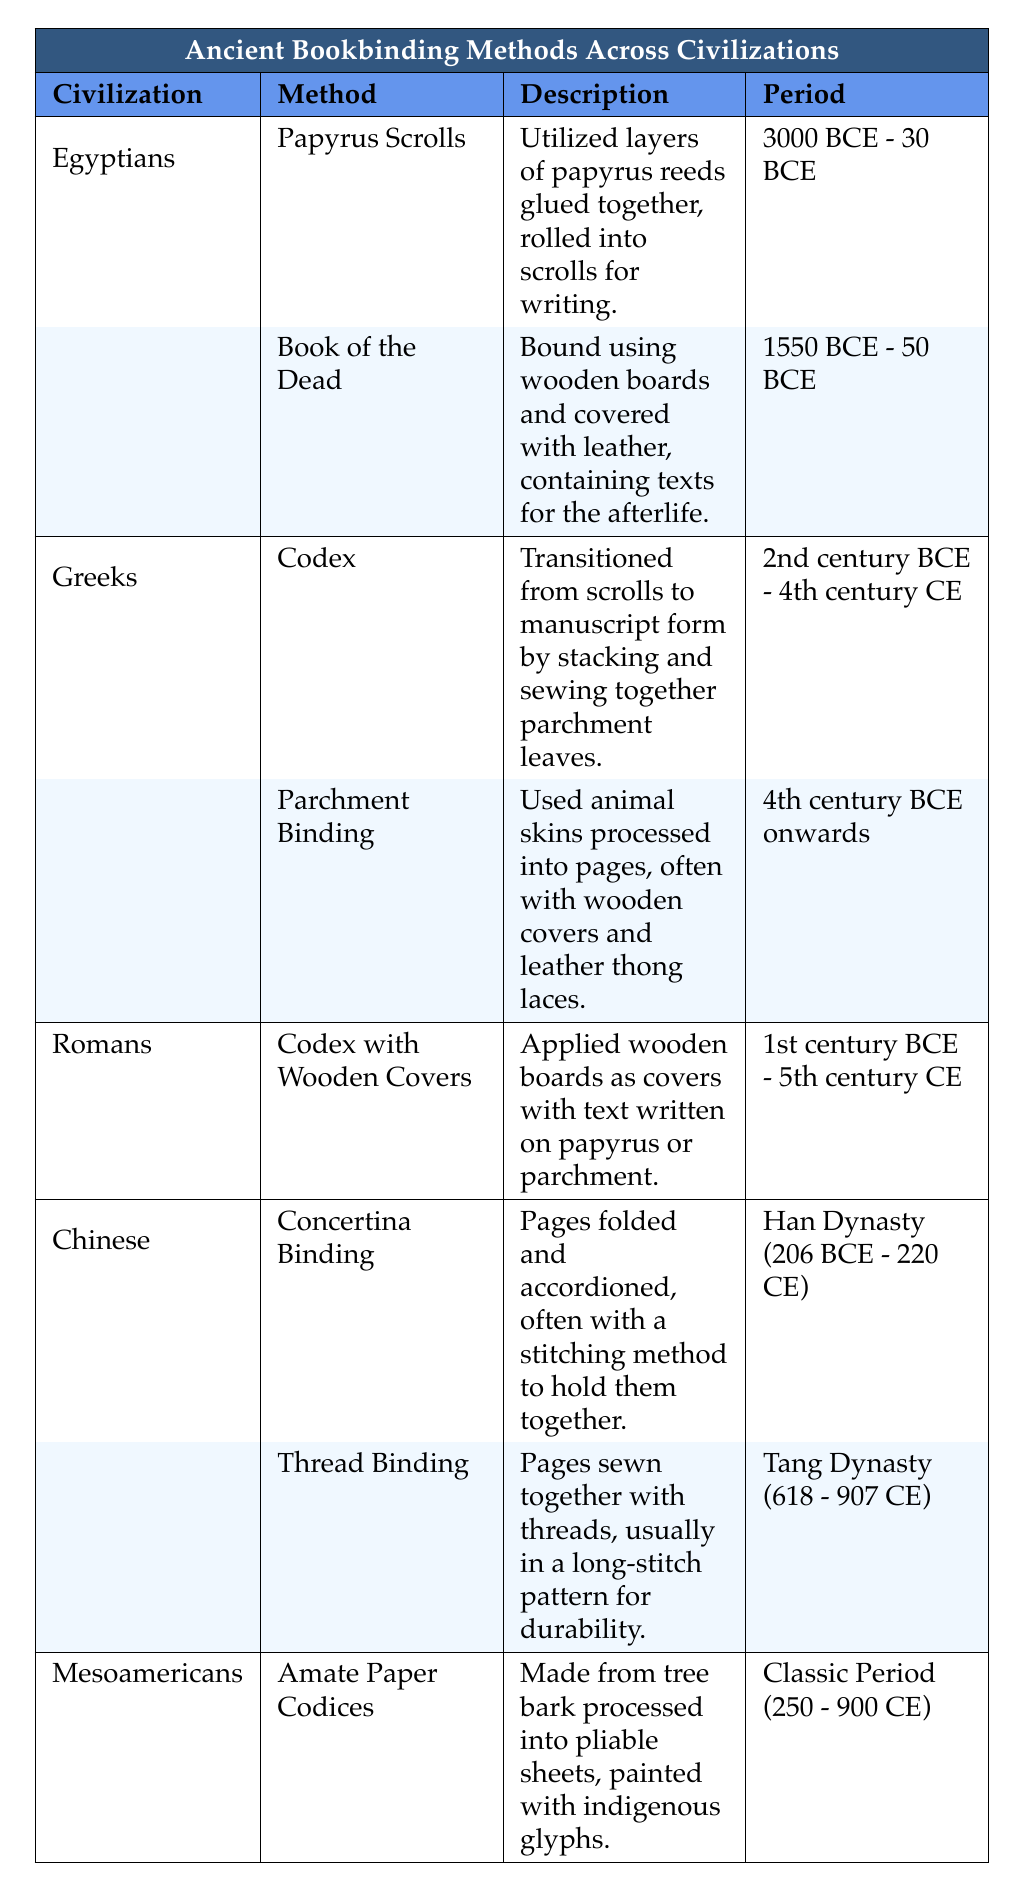What is the binding method used by the Egyptians for the Book of the Dead? The table lists the Egyptians' binding methods, including "Book of the Dead." Its description indicates that it was bound using wooden boards and covered with leather, specifically designed for texts concerning the afterlife.
Answer: Book of the Dead Which civilization developed the codex binding method? The Greeks and Romans are mentioned in the table as having different codex-related methods. Specifically, the Greeks introduced the codex as a transition from scrolls to manuscript form, while Romans applied wooden covers to a codex.
Answer: Greeks and Romans Is the Amate Paper Codices technique associated with the Tang Dynasty? The table indicates that Amate Paper Codices were created by Mesoamericans during the Classic Period (250 - 900 CE), while the Tang Dynasty is specifically mentioned for the Thread Binding method used by the Chinese. Therefore, it is not associated with the Tang Dynasty.
Answer: No What time periods were associated with the use of Parchment Binding? The table specifies that Parchment Binding began in the 4th century BCE and continued onwards, meaning it spans from that point indefinitely into the future.
Answer: 4th century BCE onwards Which ancient civilization utilized both papyrus scrolls and the Book of the Dead as binding methods? According to the table, both papyrus scrolls and the Book of the Dead methods are listed under the Egyptians, indicating that both were utilized by that civilization for their texts.
Answer: Egyptians What is the difference in the method of binding between the Greeks and the Chinese? The Greeks used methods like codex and parchment binding, which involve stacking and sewing parchment leaves or using processed animal skins, while the Chinese techniques like concertina binding and thread binding involve folding pages or sewing them with threads. Thus, the focus is on different materials and structural formats.
Answer: Different methods and materials Which binding method has the longest time span according to the table? By looking at the periods stated in the table, the "Codex with Wooden Covers" used by the Romans spans from the 1st century BCE to the 5th century CE. However, the "Parchment Binding" method used by the Greeks has no end date listed, which indicates it spans indefinitely from the 4th century BCE onwards. Hence, it has the longest time span.
Answer: Parchment Binding Did the Chinese have a bookbinding technique specifically during the Han Dynasty? The table indicates the "Concertina Binding" method was used during the Han Dynasty (206 BCE - 220 CE), confirming that there was indeed a specific binding technique during this period in Chinese history.
Answer: Yes How many different bookbinding methods were used by the Egyptians? The table shows that there are two different methods listed for the Egyptians: Papyrus Scrolls and Book of the Dead. Counting these two yields a total of two methods.
Answer: 2 